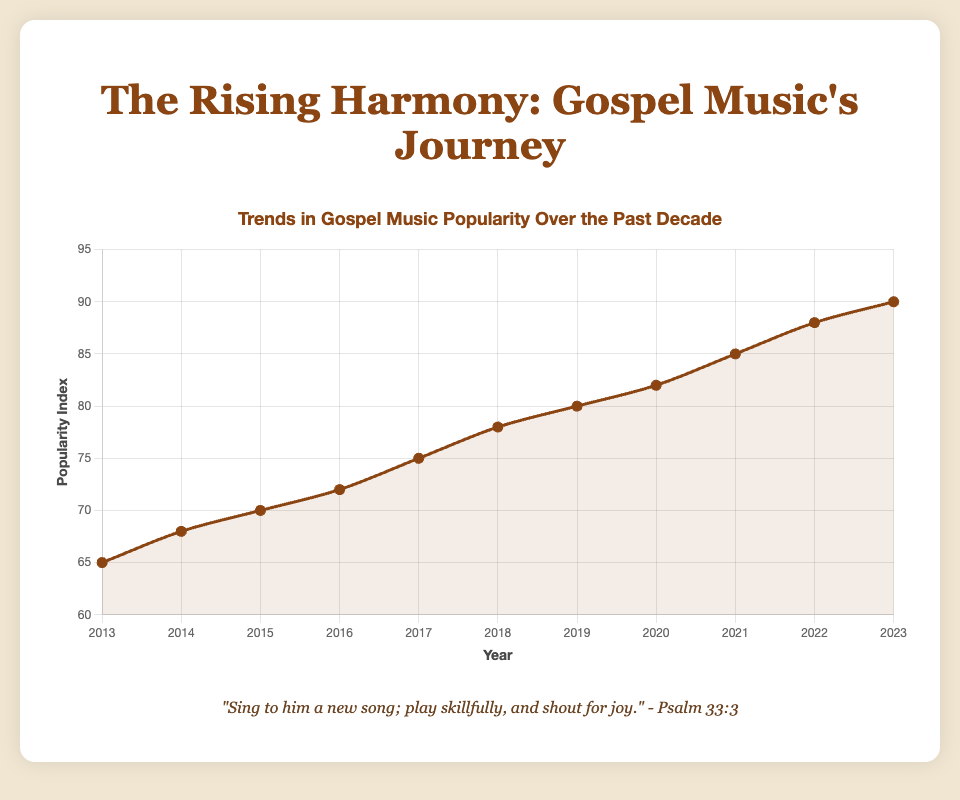What's the overall trend in the popularity of Gospel music over the past decade? The line plot shows a consistent upward trend in the Popularity Index from 2013 to 2023, indicating that Gospel music has become increasingly popular over the past decade.
Answer: Increasing Which year experienced the highest increase in the Popularity Index compared to the previous year? By evaluating the differences between consecutive years' Popularity Index values, we see the highest increase from 2021 (85) to 2022 (88), an increase of 3 points.
Answer: 2022 What is the average Popularity Index over the past decade? Sum all the Popularity Index values from 2013 to 2023 (65 + 68 + 70 + 72 + 75 + 78 + 80 + 82 + 85 + 88 + 90) = 773. Since there are 11 years, the average is 773 / 11.
Answer: 70.27 In which year did Kirk Franklin contribute to a notable increase in the popularity of Gospel music? Kirk Franklin is listed as a notable artist in 2013 and 2019. Looking at the plot, we can see that the popularity in 2019 jumped from the previous year, 2018, by 2 points (78 to 80).
Answer: 2019 What is the widest gap between two consecutive years in terms of the Popularity Index? Calculate the gaps between consecutive years’ Popularity Indexes and the widest gap is between 2021 (85) and 2022 (88), a gap of 3 points.
Answer: 3 Which year witnessed the lowest increase in the Popularity Index compared to its previous year? By calculating the differences between each year's Popularity Index, the smallest increase occurs between 2014 (68) and 2015 (70), an increase of 2 points.
Answer: 2015 How does the popularity of Gospel music in 2019 compare to that in 2023? From the line plot, the Popularity Index in 2019 is 80, while in 2023 it is 90. Thus, the popularity in 2023 is 10 points higher than in 2019.
Answer: 10 points higher Estimate the slope of the line segment between 2016 and 2018. To find the slope, use the formula (change in y)/(change in x). The change in Popularity Index from 2016 (72) to 2018 (78) is 6, and the change in years is 2. So, the slope is 6/2 = 3.
Answer: 3 